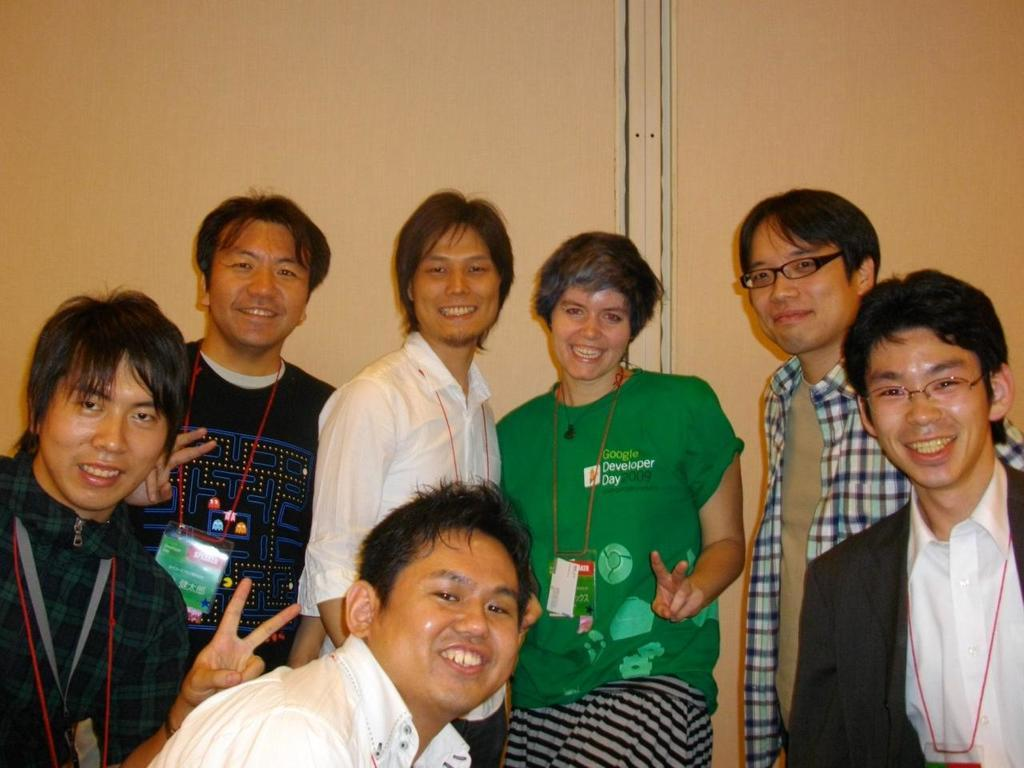What is happening with the group of people in the image? The people in the image are seeing and smiling. How are the people interacting with each other? The fact does not specify how they are interacting, but they are all smiling, which suggests a positive or happy interaction. What can be seen in the background of the image? There is a wall in the background of the image. What type of engine can be seen in the image? There is no engine present in the image; it features a group of people seeing and smiling with a wall in the background. 